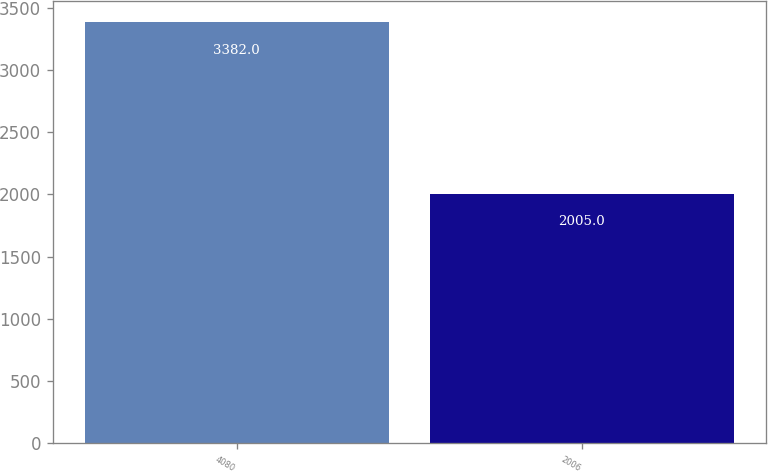<chart> <loc_0><loc_0><loc_500><loc_500><bar_chart><fcel>4080<fcel>2006<nl><fcel>3382<fcel>2005<nl></chart> 